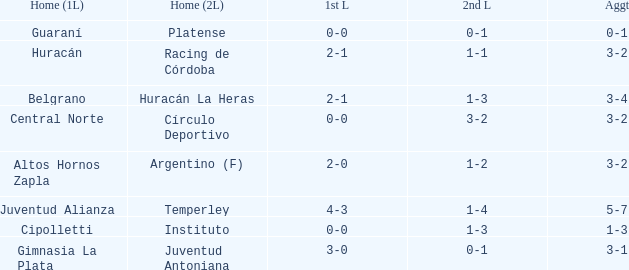Which team had their first leg at home and finished with a total score of 3-4? Belgrano. 